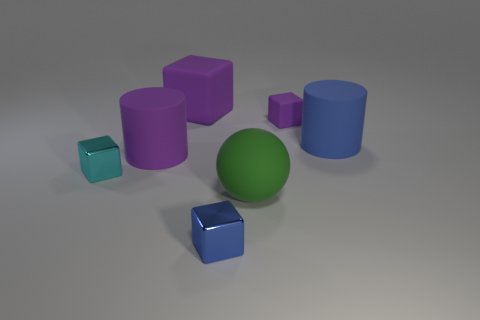Subtract all small matte cubes. How many cubes are left? 3 Subtract all purple blocks. How many blocks are left? 2 Add 2 small gray blocks. How many objects exist? 9 Subtract 1 cubes. How many cubes are left? 3 Subtract all large blue objects. Subtract all rubber objects. How many objects are left? 1 Add 3 large cylinders. How many large cylinders are left? 5 Add 3 big things. How many big things exist? 7 Subtract 1 purple cylinders. How many objects are left? 6 Subtract all cylinders. How many objects are left? 5 Subtract all cyan blocks. Subtract all gray cylinders. How many blocks are left? 3 